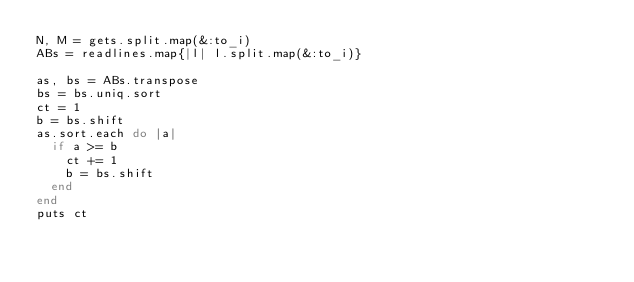<code> <loc_0><loc_0><loc_500><loc_500><_Ruby_>N, M = gets.split.map(&:to_i)
ABs = readlines.map{|l| l.split.map(&:to_i)}

as, bs = ABs.transpose
bs = bs.uniq.sort
ct = 1
b = bs.shift
as.sort.each do |a|
  if a >= b
    ct += 1
    b = bs.shift
  end
end
puts ct</code> 